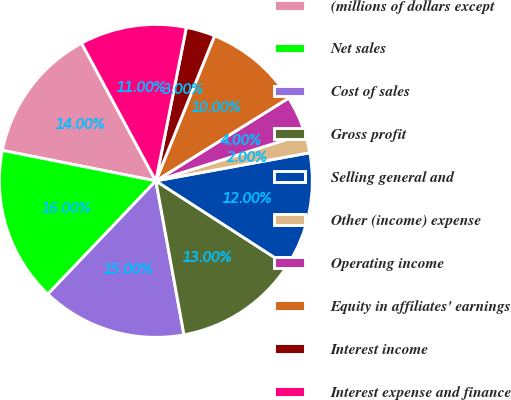<chart> <loc_0><loc_0><loc_500><loc_500><pie_chart><fcel>(millions of dollars except<fcel>Net sales<fcel>Cost of sales<fcel>Gross profit<fcel>Selling general and<fcel>Other (income) expense<fcel>Operating income<fcel>Equity in affiliates' earnings<fcel>Interest income<fcel>Interest expense and finance<nl><fcel>14.0%<fcel>16.0%<fcel>15.0%<fcel>13.0%<fcel>12.0%<fcel>2.0%<fcel>4.0%<fcel>10.0%<fcel>3.0%<fcel>11.0%<nl></chart> 